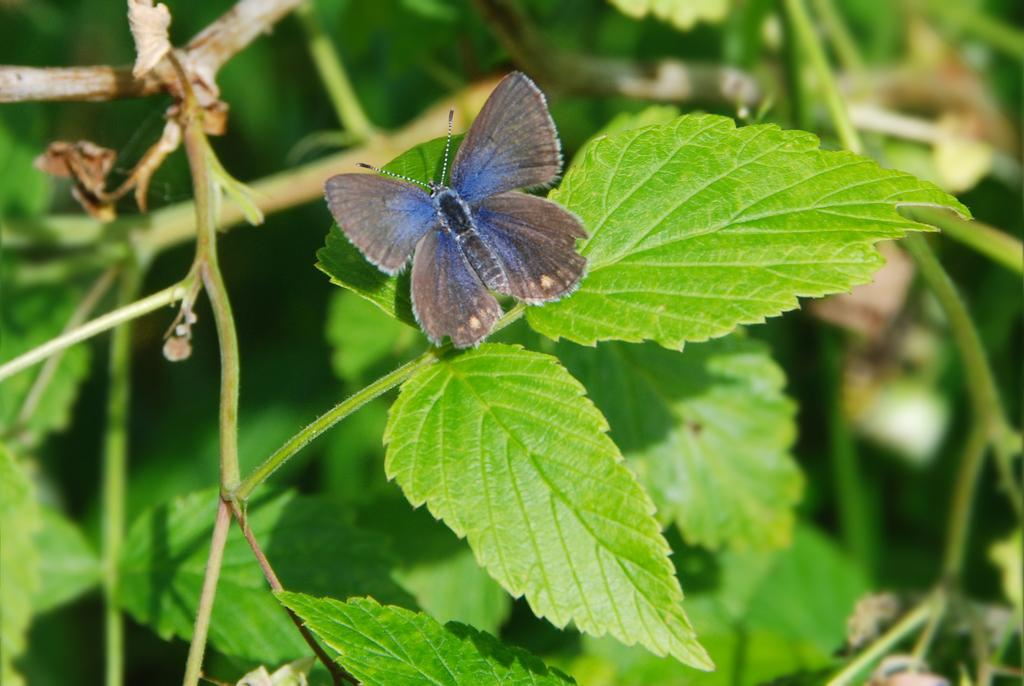What is the main subject of the image? There is a butterfly in the image. Where is the butterfly located? The butterfly is on a leaf. What color are the leaves in the image? The leaves are green in color. How many times has the tin been folded in the image? There is no tin present in the image, so it cannot be folded. 